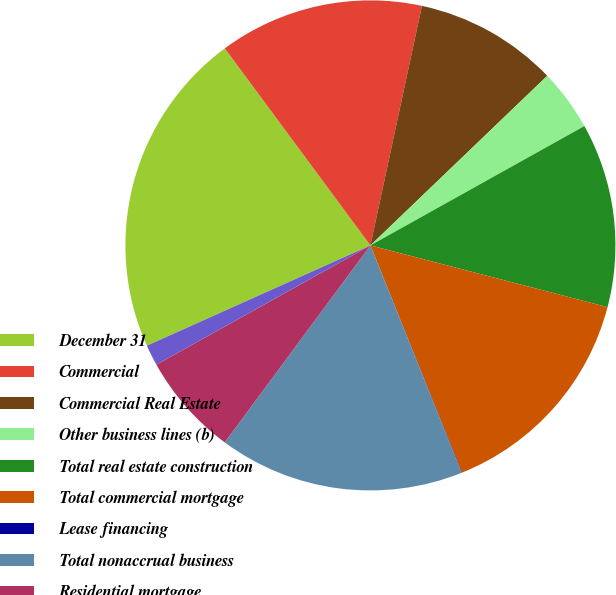Convert chart to OTSL. <chart><loc_0><loc_0><loc_500><loc_500><pie_chart><fcel>December 31<fcel>Commercial<fcel>Commercial Real Estate<fcel>Other business lines (b)<fcel>Total real estate construction<fcel>Total commercial mortgage<fcel>Lease financing<fcel>Total nonaccrual business<fcel>Residential mortgage<fcel>Home equity<nl><fcel>21.58%<fcel>13.5%<fcel>9.46%<fcel>4.07%<fcel>12.15%<fcel>14.85%<fcel>0.03%<fcel>16.2%<fcel>6.77%<fcel>1.38%<nl></chart> 